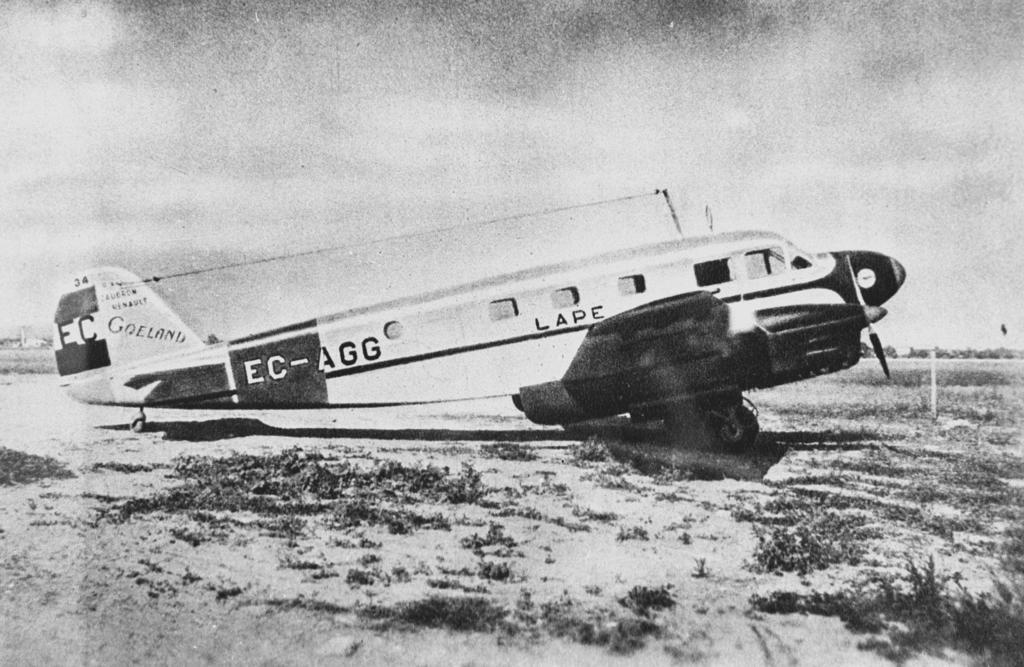<image>
Give a short and clear explanation of the subsequent image. An old propeller airplane is in a field has the word LAPE on the side of it. 